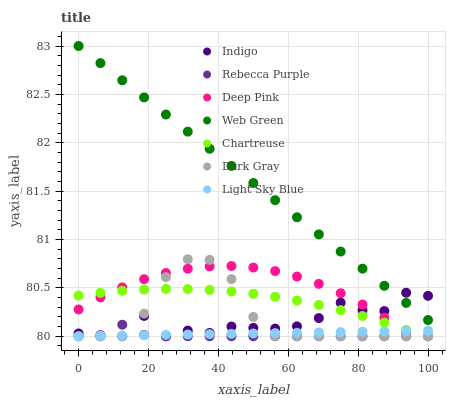Does Rebecca Purple have the minimum area under the curve?
Answer yes or no. Yes. Does Web Green have the maximum area under the curve?
Answer yes or no. Yes. Does Indigo have the minimum area under the curve?
Answer yes or no. No. Does Indigo have the maximum area under the curve?
Answer yes or no. No. Is Web Green the smoothest?
Answer yes or no. Yes. Is Indigo the roughest?
Answer yes or no. Yes. Is Indigo the smoothest?
Answer yes or no. No. Is Web Green the roughest?
Answer yes or no. No. Does Deep Pink have the lowest value?
Answer yes or no. Yes. Does Web Green have the lowest value?
Answer yes or no. No. Does Web Green have the highest value?
Answer yes or no. Yes. Does Indigo have the highest value?
Answer yes or no. No. Is Deep Pink less than Web Green?
Answer yes or no. Yes. Is Web Green greater than Deep Pink?
Answer yes or no. Yes. Does Web Green intersect Indigo?
Answer yes or no. Yes. Is Web Green less than Indigo?
Answer yes or no. No. Is Web Green greater than Indigo?
Answer yes or no. No. Does Deep Pink intersect Web Green?
Answer yes or no. No. 